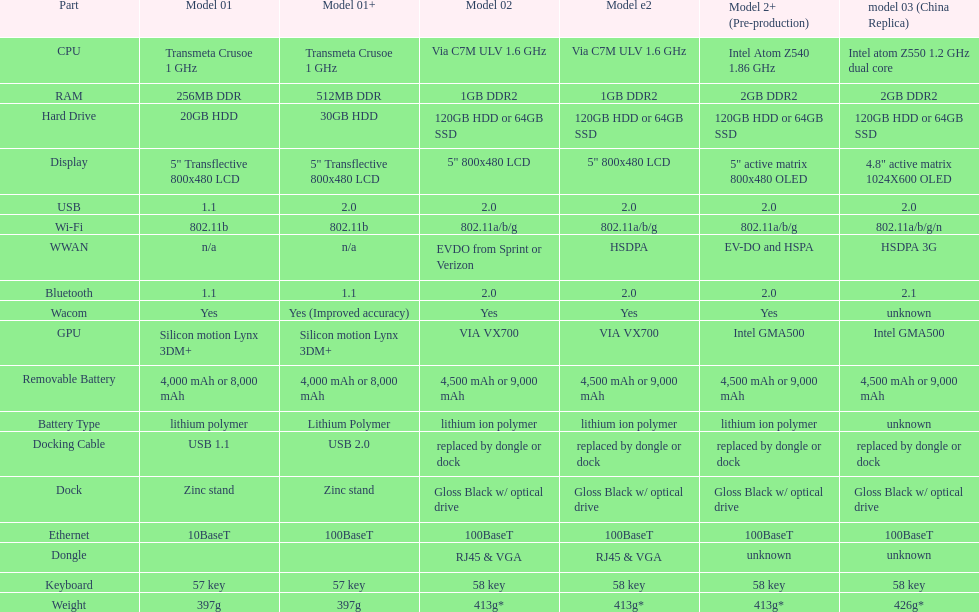Which model provides a larger hard drive: model 01 or model 02? Model 02. 